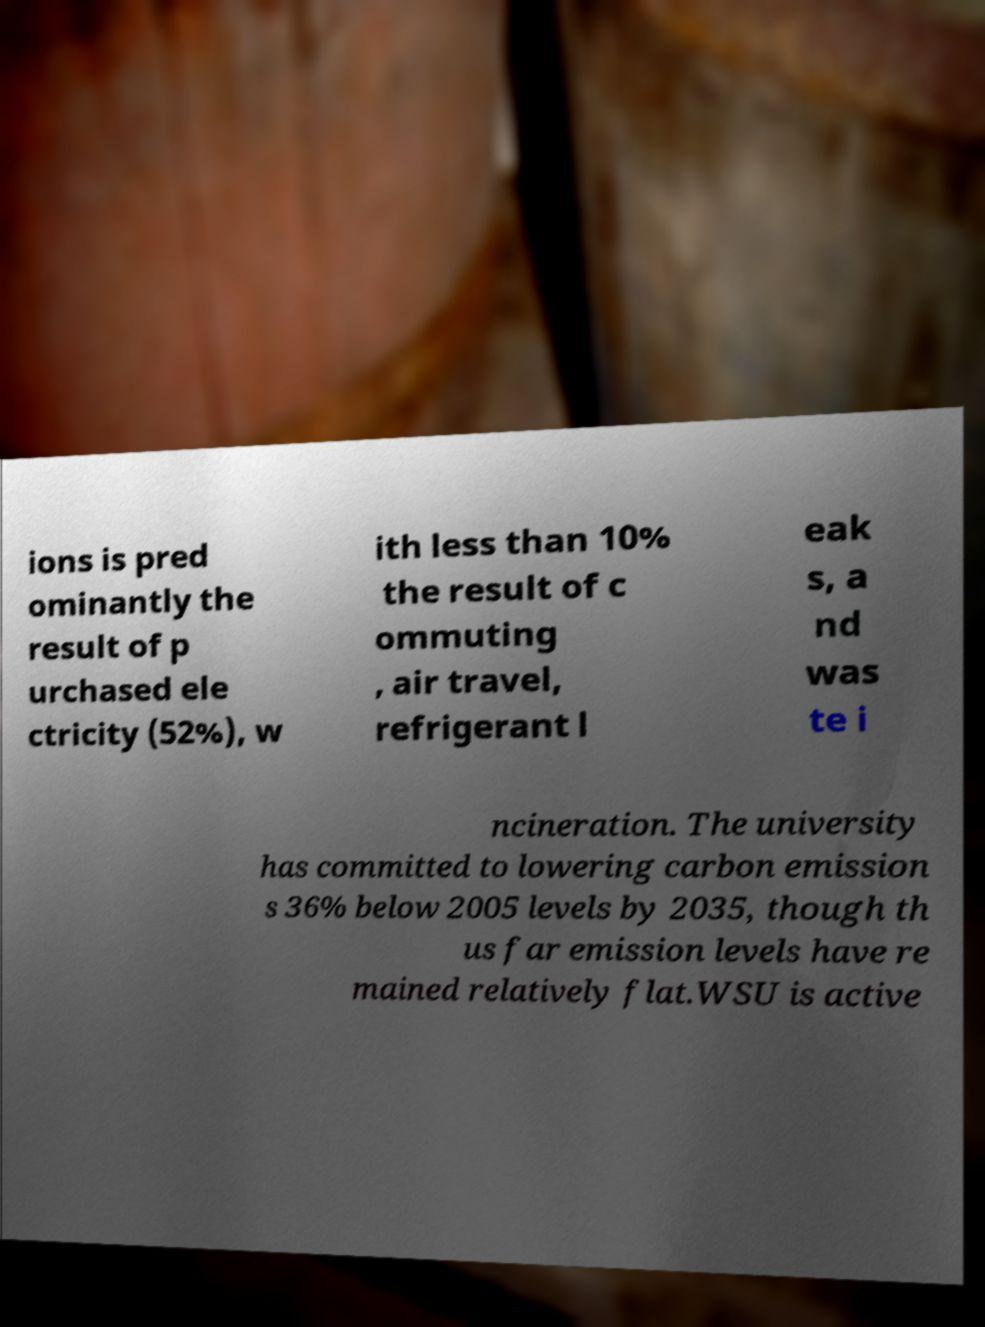What messages or text are displayed in this image? I need them in a readable, typed format. ions is pred ominantly the result of p urchased ele ctricity (52%), w ith less than 10% the result of c ommuting , air travel, refrigerant l eak s, a nd was te i ncineration. The university has committed to lowering carbon emission s 36% below 2005 levels by 2035, though th us far emission levels have re mained relatively flat.WSU is active 